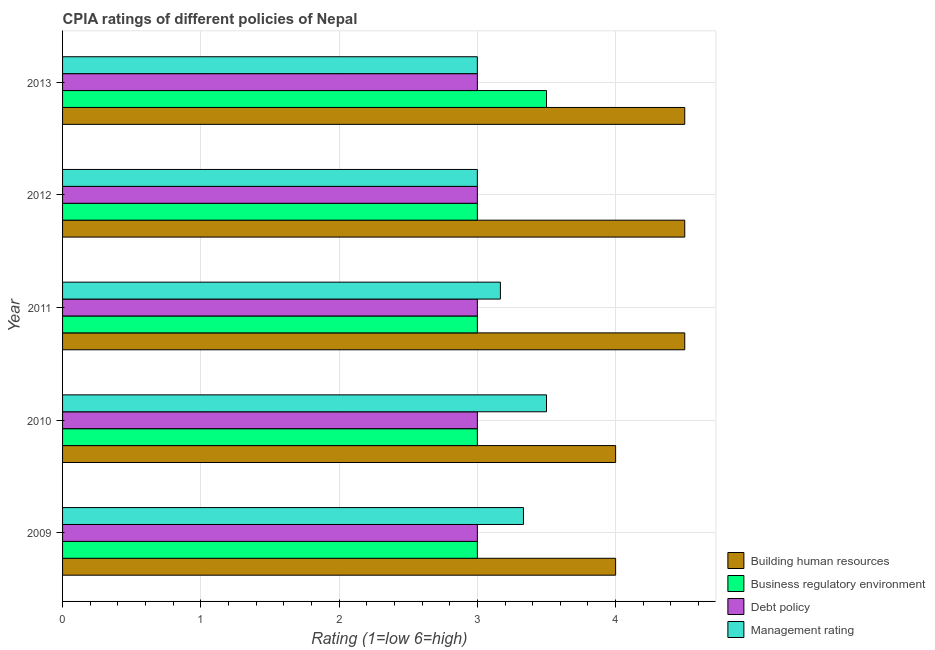How many different coloured bars are there?
Your response must be concise. 4. Are the number of bars on each tick of the Y-axis equal?
Offer a very short reply. Yes. How many bars are there on the 4th tick from the top?
Provide a short and direct response. 4. How many bars are there on the 3rd tick from the bottom?
Offer a very short reply. 4. What is the label of the 4th group of bars from the top?
Keep it short and to the point. 2010. What is the cpia rating of business regulatory environment in 2011?
Your answer should be compact. 3. Across all years, what is the maximum cpia rating of debt policy?
Give a very brief answer. 3. In which year was the cpia rating of debt policy minimum?
Ensure brevity in your answer.  2009. What is the total cpia rating of building human resources in the graph?
Offer a terse response. 21.5. What is the difference between the cpia rating of building human resources in 2013 and the cpia rating of business regulatory environment in 2012?
Ensure brevity in your answer.  1.5. In the year 2011, what is the difference between the cpia rating of debt policy and cpia rating of management?
Offer a terse response. -0.17. Is the cpia rating of building human resources in 2011 less than that in 2013?
Your answer should be compact. No. What is the difference between the highest and the lowest cpia rating of debt policy?
Make the answer very short. 0. What does the 3rd bar from the top in 2011 represents?
Offer a terse response. Business regulatory environment. What does the 1st bar from the bottom in 2012 represents?
Give a very brief answer. Building human resources. Is it the case that in every year, the sum of the cpia rating of building human resources and cpia rating of business regulatory environment is greater than the cpia rating of debt policy?
Give a very brief answer. Yes. What is the title of the graph?
Give a very brief answer. CPIA ratings of different policies of Nepal. What is the label or title of the X-axis?
Provide a succinct answer. Rating (1=low 6=high). What is the label or title of the Y-axis?
Offer a very short reply. Year. What is the Rating (1=low 6=high) of Business regulatory environment in 2009?
Ensure brevity in your answer.  3. What is the Rating (1=low 6=high) of Debt policy in 2009?
Offer a terse response. 3. What is the Rating (1=low 6=high) of Management rating in 2009?
Your answer should be compact. 3.33. What is the Rating (1=low 6=high) of Business regulatory environment in 2010?
Offer a terse response. 3. What is the Rating (1=low 6=high) in Management rating in 2010?
Ensure brevity in your answer.  3.5. What is the Rating (1=low 6=high) of Management rating in 2011?
Provide a succinct answer. 3.17. What is the Rating (1=low 6=high) of Business regulatory environment in 2012?
Give a very brief answer. 3. What is the Rating (1=low 6=high) of Building human resources in 2013?
Your response must be concise. 4.5. What is the Rating (1=low 6=high) in Business regulatory environment in 2013?
Keep it short and to the point. 3.5. What is the Rating (1=low 6=high) in Debt policy in 2013?
Your answer should be very brief. 3. Across all years, what is the maximum Rating (1=low 6=high) of Building human resources?
Provide a succinct answer. 4.5. Across all years, what is the maximum Rating (1=low 6=high) of Business regulatory environment?
Give a very brief answer. 3.5. Across all years, what is the minimum Rating (1=low 6=high) of Business regulatory environment?
Keep it short and to the point. 3. What is the total Rating (1=low 6=high) in Building human resources in the graph?
Ensure brevity in your answer.  21.5. What is the total Rating (1=low 6=high) of Debt policy in the graph?
Your answer should be compact. 15. What is the difference between the Rating (1=low 6=high) of Business regulatory environment in 2009 and that in 2010?
Make the answer very short. 0. What is the difference between the Rating (1=low 6=high) in Debt policy in 2009 and that in 2010?
Give a very brief answer. 0. What is the difference between the Rating (1=low 6=high) of Management rating in 2009 and that in 2010?
Your answer should be very brief. -0.17. What is the difference between the Rating (1=low 6=high) of Building human resources in 2009 and that in 2011?
Provide a short and direct response. -0.5. What is the difference between the Rating (1=low 6=high) in Debt policy in 2009 and that in 2011?
Give a very brief answer. 0. What is the difference between the Rating (1=low 6=high) in Management rating in 2009 and that in 2011?
Provide a succinct answer. 0.17. What is the difference between the Rating (1=low 6=high) in Business regulatory environment in 2009 and that in 2012?
Ensure brevity in your answer.  0. What is the difference between the Rating (1=low 6=high) of Building human resources in 2009 and that in 2013?
Ensure brevity in your answer.  -0.5. What is the difference between the Rating (1=low 6=high) of Debt policy in 2009 and that in 2013?
Give a very brief answer. 0. What is the difference between the Rating (1=low 6=high) in Debt policy in 2010 and that in 2011?
Make the answer very short. 0. What is the difference between the Rating (1=low 6=high) of Management rating in 2010 and that in 2011?
Give a very brief answer. 0.33. What is the difference between the Rating (1=low 6=high) in Business regulatory environment in 2010 and that in 2012?
Your response must be concise. 0. What is the difference between the Rating (1=low 6=high) in Debt policy in 2010 and that in 2012?
Your response must be concise. 0. What is the difference between the Rating (1=low 6=high) in Management rating in 2010 and that in 2012?
Keep it short and to the point. 0.5. What is the difference between the Rating (1=low 6=high) in Building human resources in 2010 and that in 2013?
Offer a terse response. -0.5. What is the difference between the Rating (1=low 6=high) of Debt policy in 2011 and that in 2012?
Give a very brief answer. 0. What is the difference between the Rating (1=low 6=high) in Management rating in 2011 and that in 2012?
Ensure brevity in your answer.  0.17. What is the difference between the Rating (1=low 6=high) of Business regulatory environment in 2011 and that in 2013?
Provide a short and direct response. -0.5. What is the difference between the Rating (1=low 6=high) of Debt policy in 2011 and that in 2013?
Provide a short and direct response. 0. What is the difference between the Rating (1=low 6=high) in Management rating in 2011 and that in 2013?
Make the answer very short. 0.17. What is the difference between the Rating (1=low 6=high) in Management rating in 2012 and that in 2013?
Offer a terse response. 0. What is the difference between the Rating (1=low 6=high) in Building human resources in 2009 and the Rating (1=low 6=high) in Debt policy in 2010?
Provide a short and direct response. 1. What is the difference between the Rating (1=low 6=high) of Building human resources in 2009 and the Rating (1=low 6=high) of Management rating in 2010?
Provide a short and direct response. 0.5. What is the difference between the Rating (1=low 6=high) of Building human resources in 2009 and the Rating (1=low 6=high) of Management rating in 2011?
Offer a very short reply. 0.83. What is the difference between the Rating (1=low 6=high) of Business regulatory environment in 2009 and the Rating (1=low 6=high) of Management rating in 2011?
Ensure brevity in your answer.  -0.17. What is the difference between the Rating (1=low 6=high) in Building human resources in 2009 and the Rating (1=low 6=high) in Business regulatory environment in 2012?
Give a very brief answer. 1. What is the difference between the Rating (1=low 6=high) in Building human resources in 2009 and the Rating (1=low 6=high) in Debt policy in 2012?
Give a very brief answer. 1. What is the difference between the Rating (1=low 6=high) in Building human resources in 2009 and the Rating (1=low 6=high) in Management rating in 2012?
Your response must be concise. 1. What is the difference between the Rating (1=low 6=high) of Business regulatory environment in 2009 and the Rating (1=low 6=high) of Management rating in 2012?
Ensure brevity in your answer.  0. What is the difference between the Rating (1=low 6=high) in Debt policy in 2009 and the Rating (1=low 6=high) in Management rating in 2012?
Provide a short and direct response. 0. What is the difference between the Rating (1=low 6=high) of Building human resources in 2009 and the Rating (1=low 6=high) of Business regulatory environment in 2013?
Offer a very short reply. 0.5. What is the difference between the Rating (1=low 6=high) of Business regulatory environment in 2009 and the Rating (1=low 6=high) of Management rating in 2013?
Make the answer very short. 0. What is the difference between the Rating (1=low 6=high) of Business regulatory environment in 2010 and the Rating (1=low 6=high) of Management rating in 2011?
Provide a short and direct response. -0.17. What is the difference between the Rating (1=low 6=high) of Building human resources in 2010 and the Rating (1=low 6=high) of Debt policy in 2012?
Offer a very short reply. 1. What is the difference between the Rating (1=low 6=high) in Building human resources in 2010 and the Rating (1=low 6=high) in Management rating in 2012?
Give a very brief answer. 1. What is the difference between the Rating (1=low 6=high) in Business regulatory environment in 2010 and the Rating (1=low 6=high) in Debt policy in 2012?
Offer a very short reply. 0. What is the difference between the Rating (1=low 6=high) in Business regulatory environment in 2010 and the Rating (1=low 6=high) in Management rating in 2012?
Offer a very short reply. 0. What is the difference between the Rating (1=low 6=high) of Debt policy in 2010 and the Rating (1=low 6=high) of Management rating in 2012?
Provide a short and direct response. 0. What is the difference between the Rating (1=low 6=high) in Building human resources in 2010 and the Rating (1=low 6=high) in Business regulatory environment in 2013?
Provide a short and direct response. 0.5. What is the difference between the Rating (1=low 6=high) of Building human resources in 2010 and the Rating (1=low 6=high) of Management rating in 2013?
Provide a short and direct response. 1. What is the difference between the Rating (1=low 6=high) in Building human resources in 2011 and the Rating (1=low 6=high) in Debt policy in 2012?
Offer a terse response. 1.5. What is the difference between the Rating (1=low 6=high) of Debt policy in 2011 and the Rating (1=low 6=high) of Management rating in 2012?
Your answer should be compact. 0. What is the difference between the Rating (1=low 6=high) in Building human resources in 2011 and the Rating (1=low 6=high) in Business regulatory environment in 2013?
Keep it short and to the point. 1. What is the difference between the Rating (1=low 6=high) of Building human resources in 2011 and the Rating (1=low 6=high) of Management rating in 2013?
Keep it short and to the point. 1.5. What is the difference between the Rating (1=low 6=high) of Business regulatory environment in 2011 and the Rating (1=low 6=high) of Debt policy in 2013?
Your answer should be compact. 0. What is the difference between the Rating (1=low 6=high) of Debt policy in 2011 and the Rating (1=low 6=high) of Management rating in 2013?
Make the answer very short. 0. What is the difference between the Rating (1=low 6=high) in Building human resources in 2012 and the Rating (1=low 6=high) in Management rating in 2013?
Provide a succinct answer. 1.5. What is the difference between the Rating (1=low 6=high) of Business regulatory environment in 2012 and the Rating (1=low 6=high) of Management rating in 2013?
Keep it short and to the point. 0. What is the difference between the Rating (1=low 6=high) of Debt policy in 2012 and the Rating (1=low 6=high) of Management rating in 2013?
Make the answer very short. 0. What is the average Rating (1=low 6=high) in Building human resources per year?
Offer a very short reply. 4.3. What is the average Rating (1=low 6=high) of Debt policy per year?
Give a very brief answer. 3. What is the average Rating (1=low 6=high) in Management rating per year?
Give a very brief answer. 3.2. In the year 2009, what is the difference between the Rating (1=low 6=high) in Building human resources and Rating (1=low 6=high) in Business regulatory environment?
Offer a terse response. 1. In the year 2009, what is the difference between the Rating (1=low 6=high) of Building human resources and Rating (1=low 6=high) of Management rating?
Your answer should be very brief. 0.67. In the year 2009, what is the difference between the Rating (1=low 6=high) of Business regulatory environment and Rating (1=low 6=high) of Management rating?
Offer a very short reply. -0.33. In the year 2010, what is the difference between the Rating (1=low 6=high) in Building human resources and Rating (1=low 6=high) in Business regulatory environment?
Offer a terse response. 1. In the year 2010, what is the difference between the Rating (1=low 6=high) in Building human resources and Rating (1=low 6=high) in Management rating?
Your response must be concise. 0.5. In the year 2010, what is the difference between the Rating (1=low 6=high) in Business regulatory environment and Rating (1=low 6=high) in Management rating?
Your answer should be very brief. -0.5. In the year 2010, what is the difference between the Rating (1=low 6=high) of Debt policy and Rating (1=low 6=high) of Management rating?
Make the answer very short. -0.5. In the year 2012, what is the difference between the Rating (1=low 6=high) in Building human resources and Rating (1=low 6=high) in Debt policy?
Ensure brevity in your answer.  1.5. In the year 2012, what is the difference between the Rating (1=low 6=high) of Business regulatory environment and Rating (1=low 6=high) of Management rating?
Provide a succinct answer. 0. In the year 2013, what is the difference between the Rating (1=low 6=high) in Building human resources and Rating (1=low 6=high) in Business regulatory environment?
Give a very brief answer. 1. In the year 2013, what is the difference between the Rating (1=low 6=high) of Building human resources and Rating (1=low 6=high) of Management rating?
Your response must be concise. 1.5. In the year 2013, what is the difference between the Rating (1=low 6=high) in Business regulatory environment and Rating (1=low 6=high) in Debt policy?
Give a very brief answer. 0.5. In the year 2013, what is the difference between the Rating (1=low 6=high) in Business regulatory environment and Rating (1=low 6=high) in Management rating?
Your response must be concise. 0.5. In the year 2013, what is the difference between the Rating (1=low 6=high) of Debt policy and Rating (1=low 6=high) of Management rating?
Your response must be concise. 0. What is the ratio of the Rating (1=low 6=high) in Building human resources in 2009 to that in 2010?
Give a very brief answer. 1. What is the ratio of the Rating (1=low 6=high) in Business regulatory environment in 2009 to that in 2010?
Give a very brief answer. 1. What is the ratio of the Rating (1=low 6=high) in Debt policy in 2009 to that in 2010?
Give a very brief answer. 1. What is the ratio of the Rating (1=low 6=high) in Management rating in 2009 to that in 2010?
Provide a short and direct response. 0.95. What is the ratio of the Rating (1=low 6=high) in Building human resources in 2009 to that in 2011?
Provide a short and direct response. 0.89. What is the ratio of the Rating (1=low 6=high) in Business regulatory environment in 2009 to that in 2011?
Ensure brevity in your answer.  1. What is the ratio of the Rating (1=low 6=high) of Management rating in 2009 to that in 2011?
Provide a succinct answer. 1.05. What is the ratio of the Rating (1=low 6=high) in Building human resources in 2009 to that in 2012?
Your answer should be compact. 0.89. What is the ratio of the Rating (1=low 6=high) of Business regulatory environment in 2009 to that in 2012?
Provide a short and direct response. 1. What is the ratio of the Rating (1=low 6=high) of Business regulatory environment in 2009 to that in 2013?
Offer a very short reply. 0.86. What is the ratio of the Rating (1=low 6=high) in Management rating in 2009 to that in 2013?
Your answer should be very brief. 1.11. What is the ratio of the Rating (1=low 6=high) in Building human resources in 2010 to that in 2011?
Keep it short and to the point. 0.89. What is the ratio of the Rating (1=low 6=high) in Business regulatory environment in 2010 to that in 2011?
Your response must be concise. 1. What is the ratio of the Rating (1=low 6=high) in Debt policy in 2010 to that in 2011?
Make the answer very short. 1. What is the ratio of the Rating (1=low 6=high) in Management rating in 2010 to that in 2011?
Provide a short and direct response. 1.11. What is the ratio of the Rating (1=low 6=high) of Building human resources in 2010 to that in 2012?
Your answer should be very brief. 0.89. What is the ratio of the Rating (1=low 6=high) of Business regulatory environment in 2010 to that in 2012?
Your response must be concise. 1. What is the ratio of the Rating (1=low 6=high) of Building human resources in 2010 to that in 2013?
Offer a very short reply. 0.89. What is the ratio of the Rating (1=low 6=high) in Business regulatory environment in 2010 to that in 2013?
Provide a succinct answer. 0.86. What is the ratio of the Rating (1=low 6=high) of Management rating in 2010 to that in 2013?
Ensure brevity in your answer.  1.17. What is the ratio of the Rating (1=low 6=high) in Management rating in 2011 to that in 2012?
Offer a very short reply. 1.06. What is the ratio of the Rating (1=low 6=high) in Building human resources in 2011 to that in 2013?
Ensure brevity in your answer.  1. What is the ratio of the Rating (1=low 6=high) in Debt policy in 2011 to that in 2013?
Offer a very short reply. 1. What is the ratio of the Rating (1=low 6=high) of Management rating in 2011 to that in 2013?
Keep it short and to the point. 1.06. What is the ratio of the Rating (1=low 6=high) of Building human resources in 2012 to that in 2013?
Ensure brevity in your answer.  1. What is the ratio of the Rating (1=low 6=high) of Debt policy in 2012 to that in 2013?
Offer a terse response. 1. What is the difference between the highest and the second highest Rating (1=low 6=high) in Debt policy?
Keep it short and to the point. 0. What is the difference between the highest and the lowest Rating (1=low 6=high) of Business regulatory environment?
Provide a short and direct response. 0.5. What is the difference between the highest and the lowest Rating (1=low 6=high) in Management rating?
Keep it short and to the point. 0.5. 